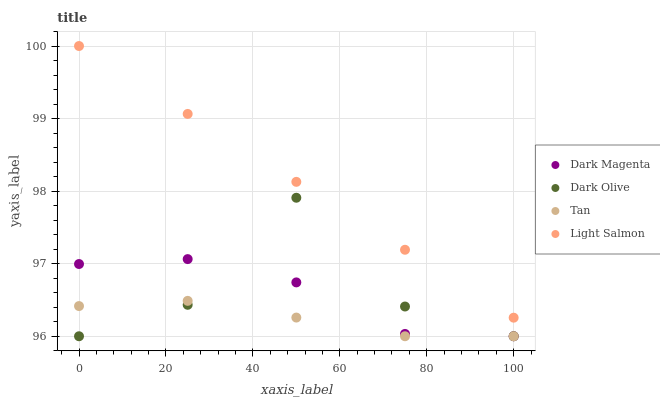Does Tan have the minimum area under the curve?
Answer yes or no. Yes. Does Light Salmon have the maximum area under the curve?
Answer yes or no. Yes. Does Dark Olive have the minimum area under the curve?
Answer yes or no. No. Does Dark Olive have the maximum area under the curve?
Answer yes or no. No. Is Light Salmon the smoothest?
Answer yes or no. Yes. Is Dark Olive the roughest?
Answer yes or no. Yes. Is Dark Magenta the smoothest?
Answer yes or no. No. Is Dark Magenta the roughest?
Answer yes or no. No. Does Tan have the lowest value?
Answer yes or no. Yes. Does Light Salmon have the lowest value?
Answer yes or no. No. Does Light Salmon have the highest value?
Answer yes or no. Yes. Does Dark Olive have the highest value?
Answer yes or no. No. Is Dark Magenta less than Light Salmon?
Answer yes or no. Yes. Is Light Salmon greater than Tan?
Answer yes or no. Yes. Does Dark Magenta intersect Dark Olive?
Answer yes or no. Yes. Is Dark Magenta less than Dark Olive?
Answer yes or no. No. Is Dark Magenta greater than Dark Olive?
Answer yes or no. No. Does Dark Magenta intersect Light Salmon?
Answer yes or no. No. 